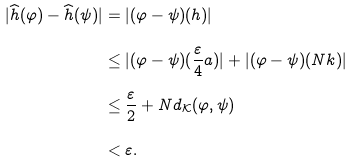<formula> <loc_0><loc_0><loc_500><loc_500>| \widehat { h } ( \varphi ) - \widehat { h } ( \psi ) | & = | ( \varphi - \psi ) ( h ) | \\ & \leq | ( \varphi - \psi ) ( \frac { \varepsilon } { 4 } a ) | + | ( \varphi - \psi ) ( N k ) | \\ & \leq \frac { \varepsilon } { 2 } + N d _ { \mathcal { K } } ( \varphi , \psi ) \\ & < \varepsilon .</formula> 